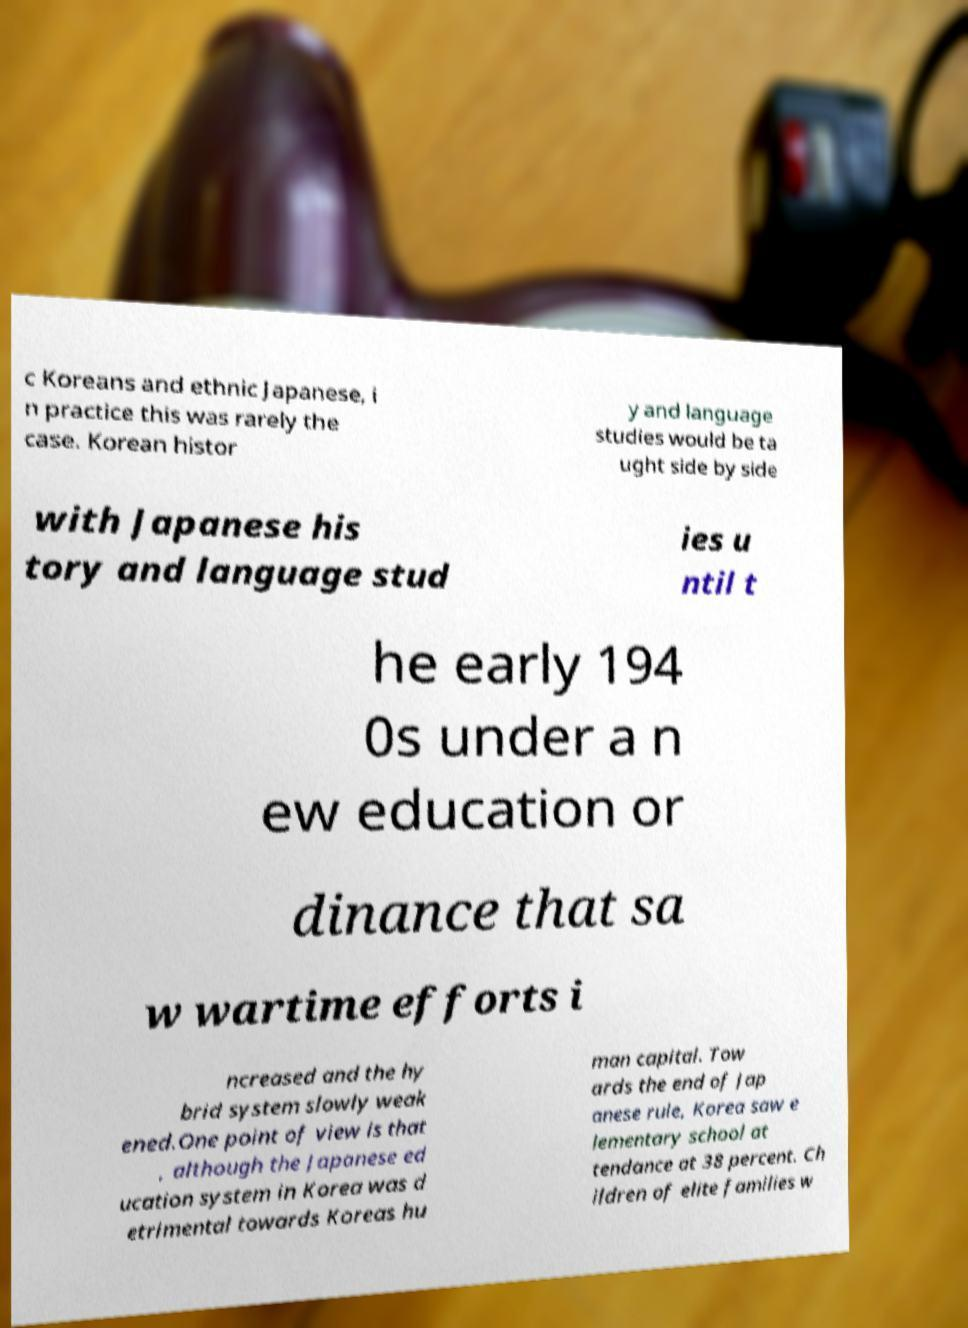Could you extract and type out the text from this image? c Koreans and ethnic Japanese, i n practice this was rarely the case. Korean histor y and language studies would be ta ught side by side with Japanese his tory and language stud ies u ntil t he early 194 0s under a n ew education or dinance that sa w wartime efforts i ncreased and the hy brid system slowly weak ened.One point of view is that , although the Japanese ed ucation system in Korea was d etrimental towards Koreas hu man capital. Tow ards the end of Jap anese rule, Korea saw e lementary school at tendance at 38 percent. Ch ildren of elite families w 